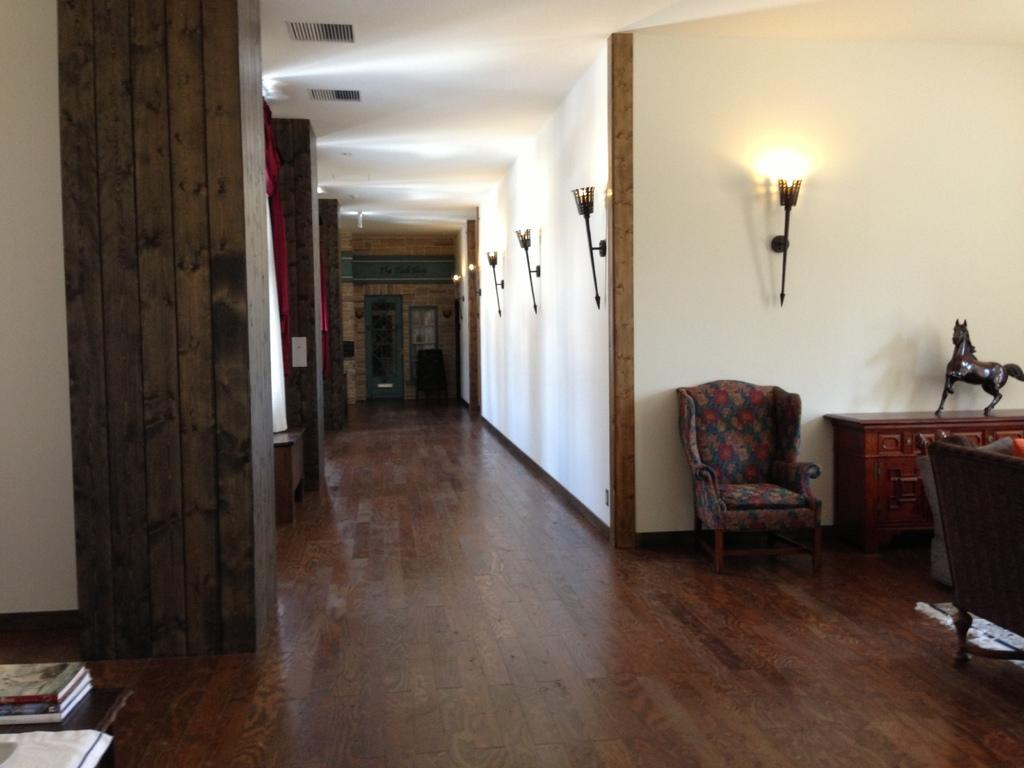What type of space is depicted in the image? The image shows an inner view of a room. What piece of furniture can be seen in the room? There is a chair in the room. Is there any source of illumination in the room? Yes, there is a light in the room. What type of object can be found in the room that is typically associated with play? There is a toy in the room. What can be found on the table in the room? There are books on a table in the room. How many bottles of wine are visible on the table in the image? There are no bottles of wine present in the image; it only shows books on the table. What type of animal is biting the chair leg in the image? There is no animal present in the image, and therefore no biting can be observed. 